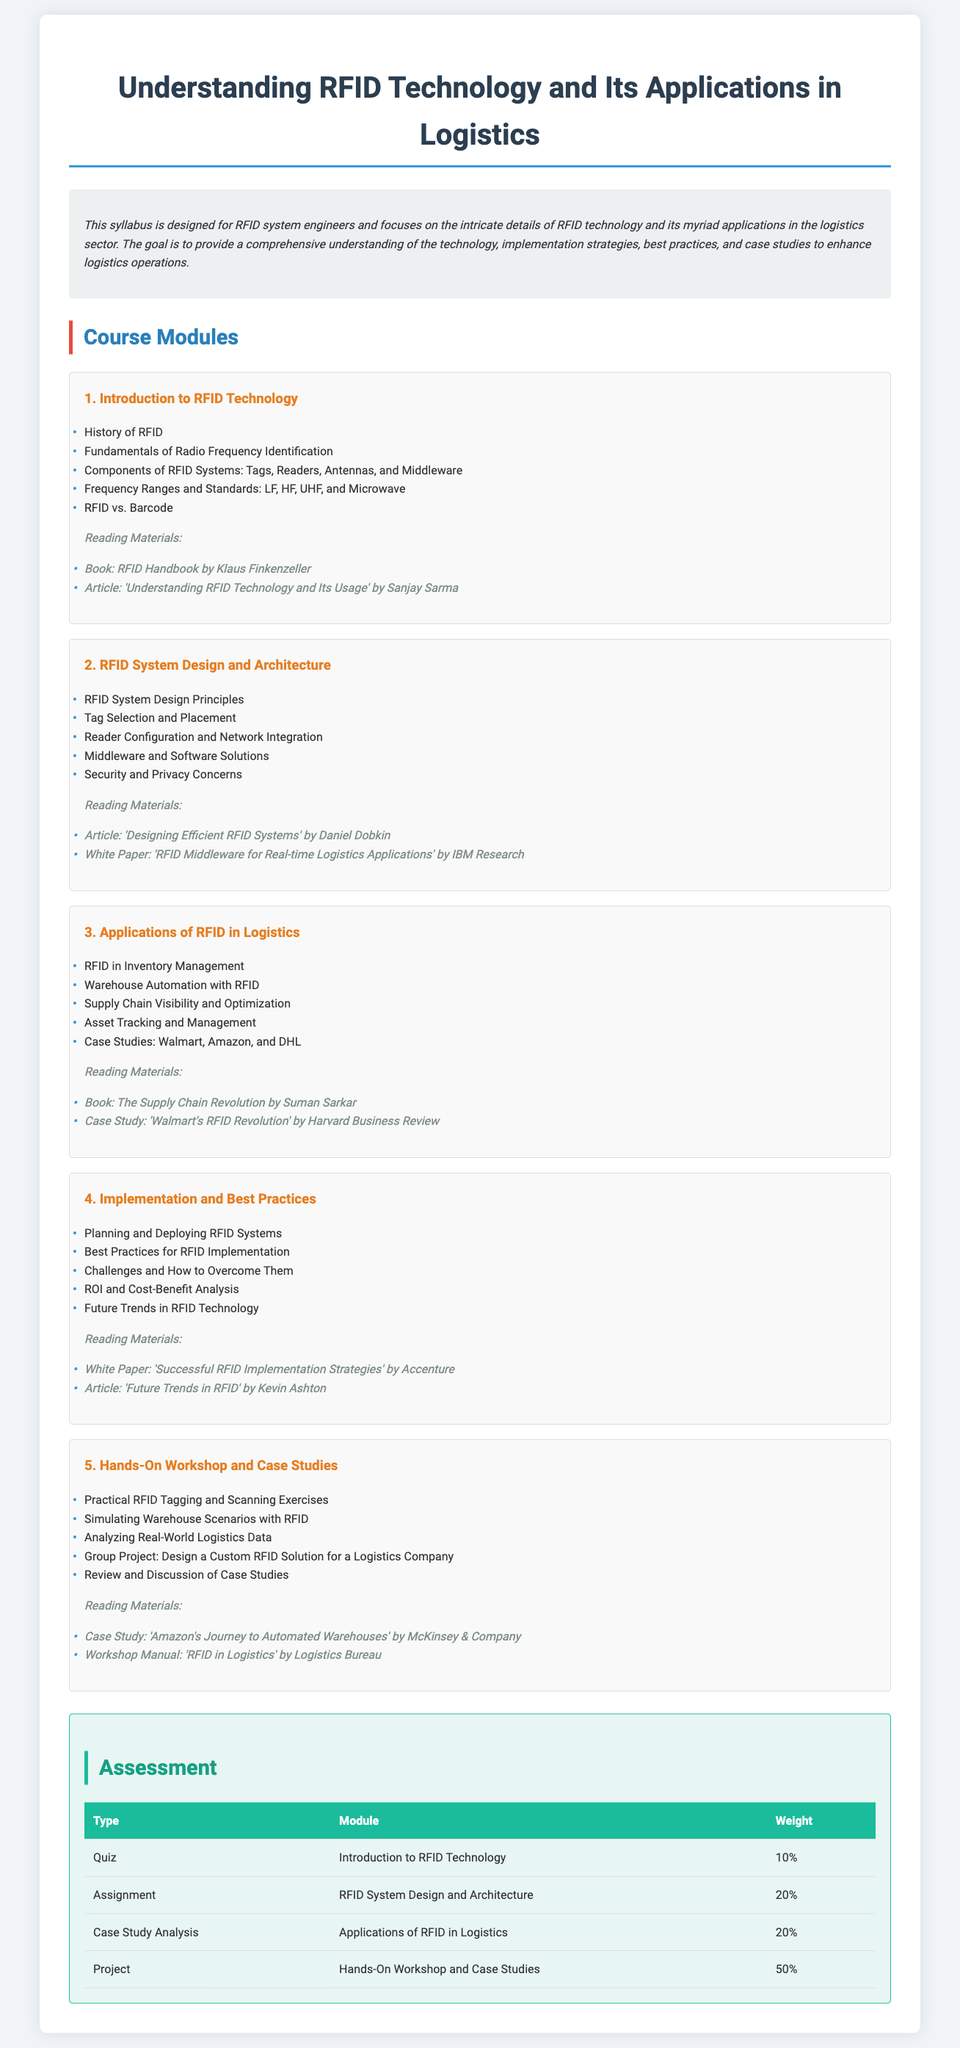What is the title of the syllabus? The title of the syllabus is mentioned at the top of the document as "Understanding RFID Technology and Its Applications in Logistics."
Answer: Understanding RFID Technology and Its Applications in Logistics Who is the target audience for this syllabus? The target audience is specified in the overview as RFID system engineers.
Answer: RFID system engineers How many modules are included in the syllabus? The document lists five distinct modules in the course structure.
Answer: 5 What is the weight of the project assessment? The weight of the project assessment is detailed in the assessment section of the document.
Answer: 50% Which book is suggested for reading in the "Introduction to RFID Technology" module? The reading materials section under the first module lists "RFID Handbook by Klaus Finkenzeller."
Answer: RFID Handbook by Klaus Finkenzeller What is the last module focused on? The last module is titled "Hands-On Workshop and Case Studies," indicating a practical approach.
Answer: Hands-On Workshop and Case Studies What percentage weight is assigned to the quiz in the assessment? The specific percentage weight assigned to the quiz can be found in the assessment table within the document.
Answer: 10% Name one case study mentioned in the syllabus. The document mentions a case study titled "Walmart's RFID Revolution" in the Applications module.
Answer: Walmart's RFID Revolution 